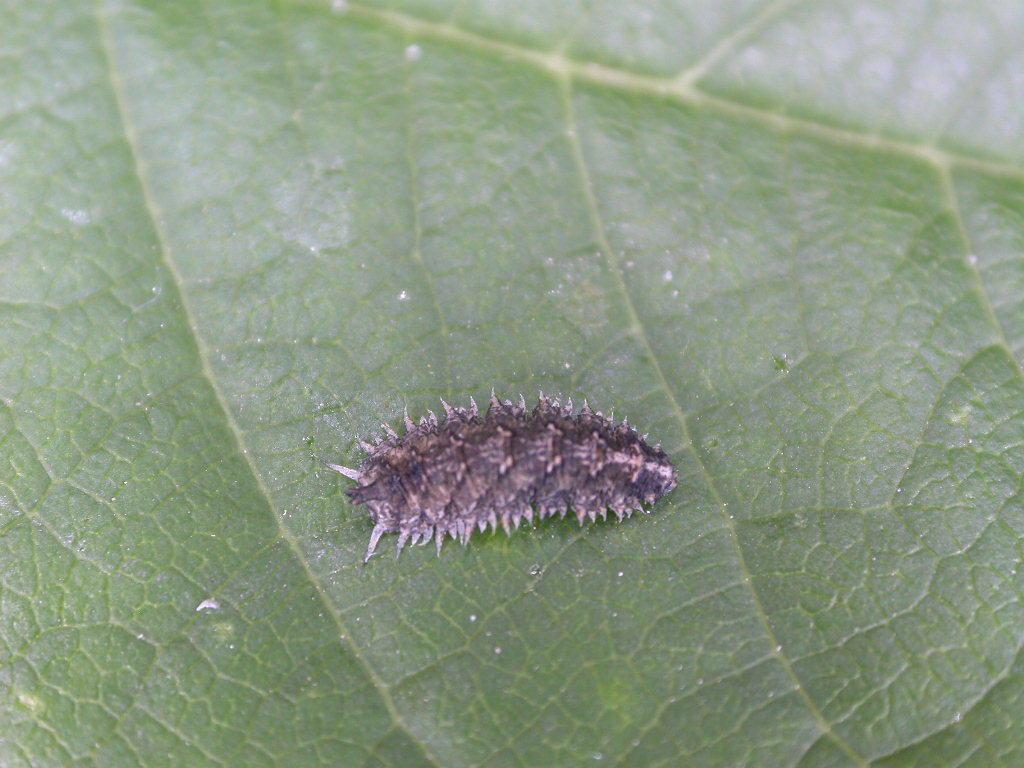Describe this image in one or two sentences. In this image there is a green leaf and in the middle of the image there is an insect on the leaf. 